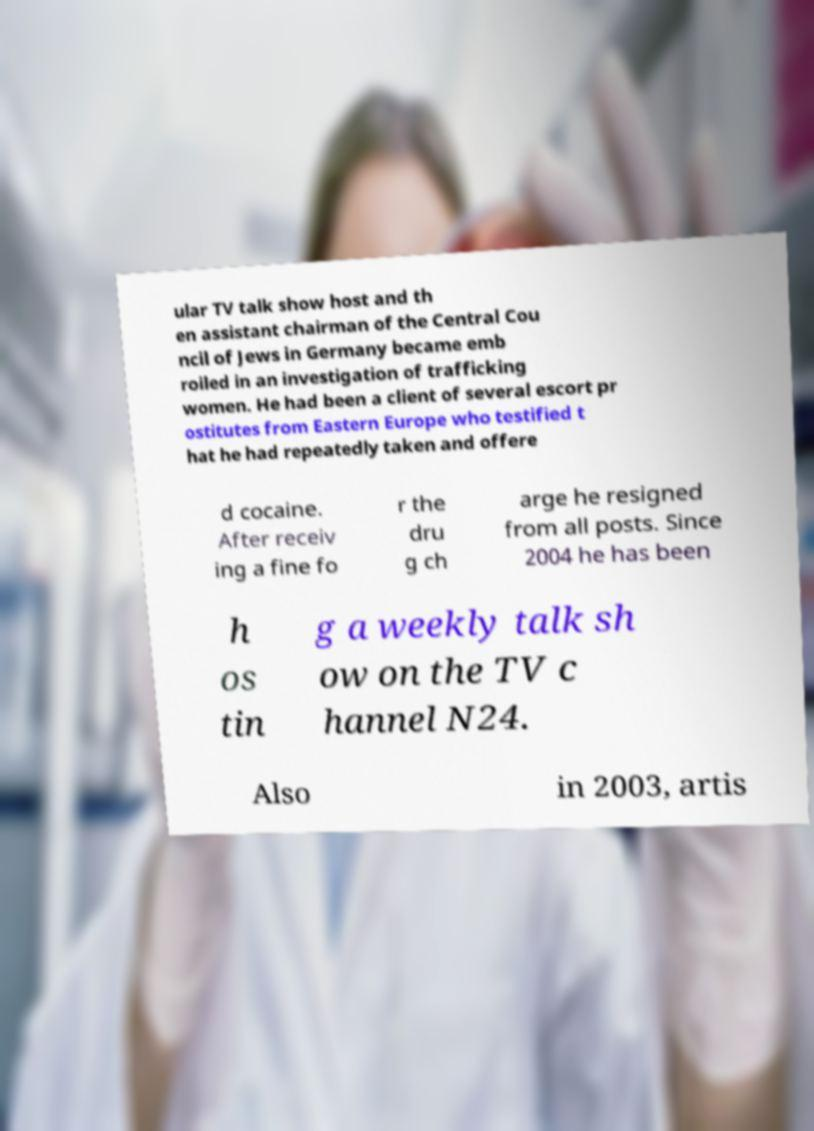Please read and relay the text visible in this image. What does it say? ular TV talk show host and th en assistant chairman of the Central Cou ncil of Jews in Germany became emb roiled in an investigation of trafficking women. He had been a client of several escort pr ostitutes from Eastern Europe who testified t hat he had repeatedly taken and offere d cocaine. After receiv ing a fine fo r the dru g ch arge he resigned from all posts. Since 2004 he has been h os tin g a weekly talk sh ow on the TV c hannel N24. Also in 2003, artis 